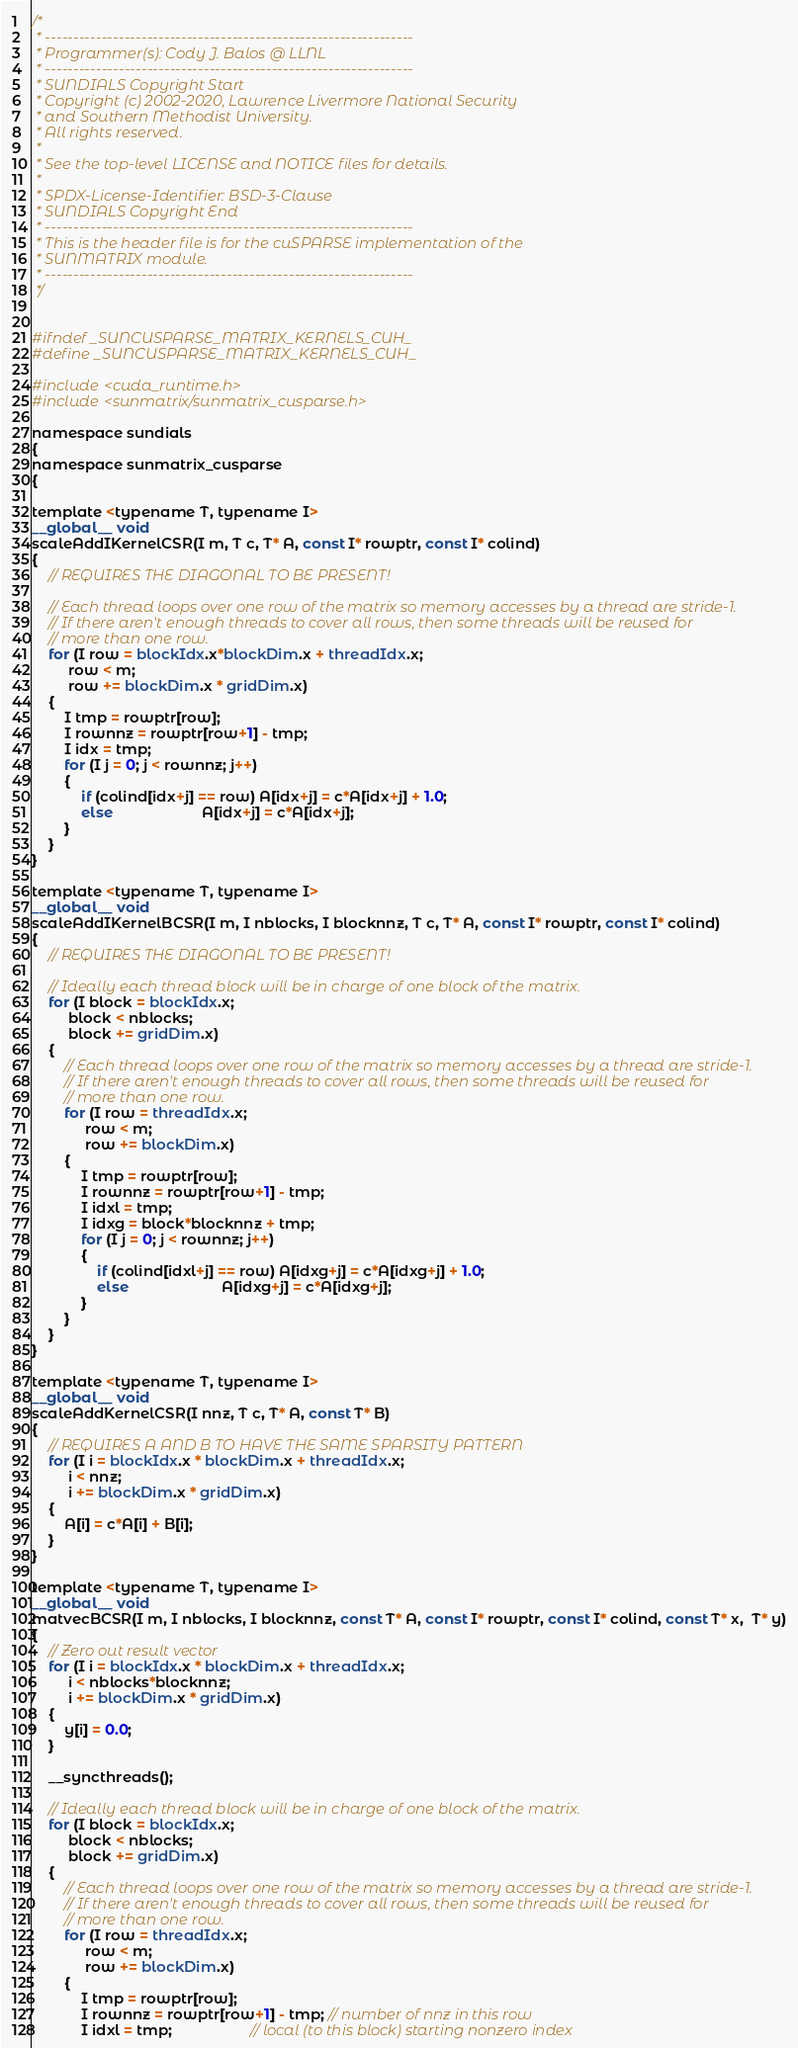<code> <loc_0><loc_0><loc_500><loc_500><_Cuda_>/*
 * -----------------------------------------------------------------
 * Programmer(s): Cody J. Balos @ LLNL
 * -----------------------------------------------------------------
 * SUNDIALS Copyright Start
 * Copyright (c) 2002-2020, Lawrence Livermore National Security
 * and Southern Methodist University.
 * All rights reserved.
 *
 * See the top-level LICENSE and NOTICE files for details.
 *
 * SPDX-License-Identifier: BSD-3-Clause
 * SUNDIALS Copyright End
 * -----------------------------------------------------------------
 * This is the header file is for the cuSPARSE implementation of the
 * SUNMATRIX module.
 * -----------------------------------------------------------------
 */


#ifndef _SUNCUSPARSE_MATRIX_KERNELS_CUH_
#define _SUNCUSPARSE_MATRIX_KERNELS_CUH_

#include <cuda_runtime.h>
#include <sunmatrix/sunmatrix_cusparse.h>

namespace sundials
{
namespace sunmatrix_cusparse
{

template <typename T, typename I>
__global__ void
scaleAddIKernelCSR(I m, T c, T* A, const I* rowptr, const I* colind)
{
    // REQUIRES THE DIAGONAL TO BE PRESENT!

    // Each thread loops over one row of the matrix so memory accesses by a thread are stride-1.
    // If there aren't enough threads to cover all rows, then some threads will be reused for
    // more than one row.
    for (I row = blockIdx.x*blockDim.x + threadIdx.x;
         row < m;
         row += blockDim.x * gridDim.x)
    {
        I tmp = rowptr[row];
        I rownnz = rowptr[row+1] - tmp;
        I idx = tmp;
        for (I j = 0; j < rownnz; j++)
        {
            if (colind[idx+j] == row) A[idx+j] = c*A[idx+j] + 1.0;
            else                      A[idx+j] = c*A[idx+j];
        }
    }
}

template <typename T, typename I>
__global__ void
scaleAddIKernelBCSR(I m, I nblocks, I blocknnz, T c, T* A, const I* rowptr, const I* colind)
{
    // REQUIRES THE DIAGONAL TO BE PRESENT!

    // Ideally each thread block will be in charge of one block of the matrix.
    for (I block = blockIdx.x;
         block < nblocks;
         block += gridDim.x)
    {
        // Each thread loops over one row of the matrix so memory accesses by a thread are stride-1.
        // If there aren't enough threads to cover all rows, then some threads will be reused for
        // more than one row.
        for (I row = threadIdx.x;
             row < m;
             row += blockDim.x)
        {
            I tmp = rowptr[row];
            I rownnz = rowptr[row+1] - tmp;
            I idxl = tmp;
            I idxg = block*blocknnz + tmp;
            for (I j = 0; j < rownnz; j++)
            {
                if (colind[idxl+j] == row) A[idxg+j] = c*A[idxg+j] + 1.0;
                else                       A[idxg+j] = c*A[idxg+j];
            }
        }
    }
}

template <typename T, typename I>
__global__ void
scaleAddKernelCSR(I nnz, T c, T* A, const T* B)
{
    // REQUIRES A AND B TO HAVE THE SAME SPARSITY PATTERN
    for (I i = blockIdx.x * blockDim.x + threadIdx.x;
         i < nnz;
         i += blockDim.x * gridDim.x)
    {
        A[i] = c*A[i] + B[i];
    }
}

template <typename T, typename I>
__global__ void
matvecBCSR(I m, I nblocks, I blocknnz, const T* A, const I* rowptr, const I* colind, const T* x,  T* y)
{
    // Zero out result vector
    for (I i = blockIdx.x * blockDim.x + threadIdx.x;
         i < nblocks*blocknnz;
         i += blockDim.x * gridDim.x)
    {
        y[i] = 0.0;
    }

    __syncthreads();

    // Ideally each thread block will be in charge of one block of the matrix.
    for (I block = blockIdx.x;
         block < nblocks;
         block += gridDim.x)
    {
        // Each thread loops over one row of the matrix so memory accesses by a thread are stride-1.
        // If there aren't enough threads to cover all rows, then some threads will be reused for
        // more than one row.
        for (I row = threadIdx.x;
             row < m;
             row += blockDim.x)
        {
            I tmp = rowptr[row];
            I rownnz = rowptr[row+1] - tmp; // number of nnz in this row
            I idxl = tmp;                   // local (to this block) starting nonzero index</code> 